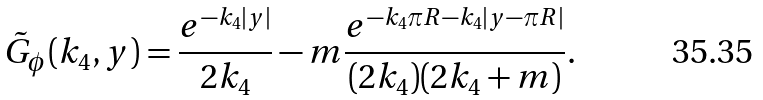<formula> <loc_0><loc_0><loc_500><loc_500>\tilde { G } _ { \phi } ( k _ { 4 } , y ) = \frac { e ^ { - k _ { 4 } | y | } } { 2 k _ { 4 } } - m \frac { e ^ { - k _ { 4 } \pi R - k _ { 4 } | y - \pi R | } } { ( 2 k _ { 4 } ) ( 2 k _ { 4 } + m ) } .</formula> 